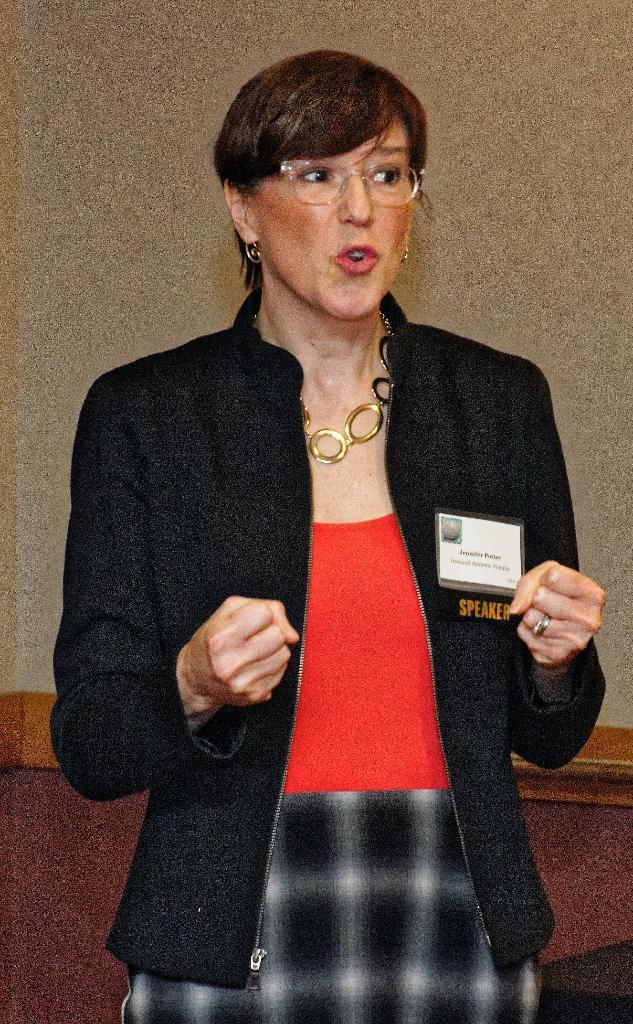Describe this image in one or two sentences. In this picture I can see a woman in front who is standing and I see that she is wearing black, red and white color dress and I see a necklace around her neck. In the background I can see the wall. 